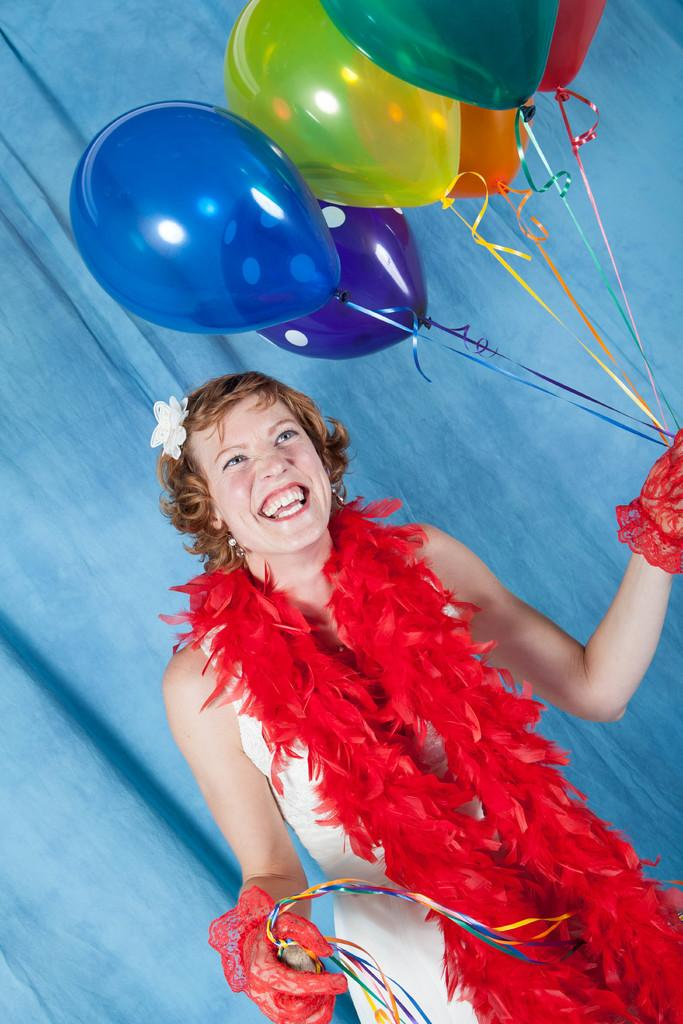Who is the main subject in the foreground of the image? There is a woman in the foreground of the image. What is the woman holding in her hand? The woman is holding balloons in her hand. What can be seen in the background of the image? There is a curtain in the background of the image. Where might this image have been taken? The image may have been taken in a hall, based on the presence of a curtain. How many plates can be seen on the table in the image? There is no table or plates present in the image; it features a woman holding balloons and a curtain in the background. 